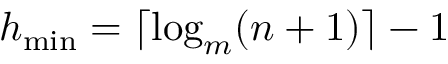<formula> <loc_0><loc_0><loc_500><loc_500>h _ { \min } = \lceil \log _ { m } ( n + 1 ) \rceil - 1</formula> 